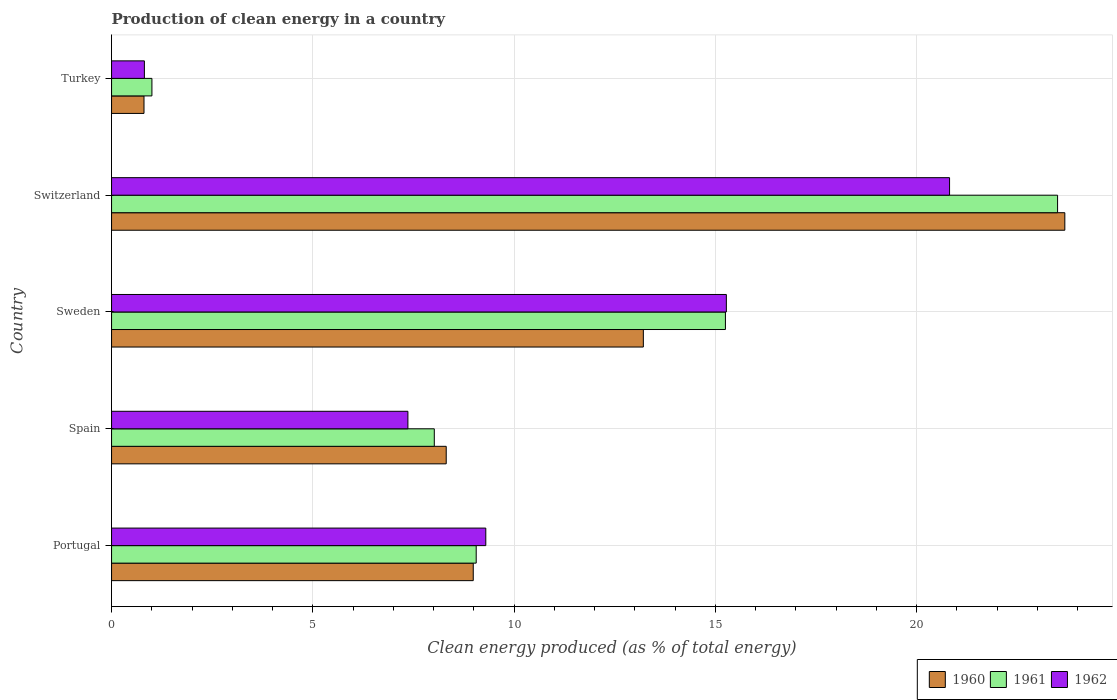Are the number of bars on each tick of the Y-axis equal?
Provide a succinct answer. Yes. How many bars are there on the 1st tick from the top?
Your answer should be compact. 3. How many bars are there on the 3rd tick from the bottom?
Provide a short and direct response. 3. What is the label of the 2nd group of bars from the top?
Your response must be concise. Switzerland. In how many cases, is the number of bars for a given country not equal to the number of legend labels?
Your response must be concise. 0. What is the percentage of clean energy produced in 1960 in Spain?
Give a very brief answer. 8.31. Across all countries, what is the maximum percentage of clean energy produced in 1961?
Offer a very short reply. 23.5. Across all countries, what is the minimum percentage of clean energy produced in 1960?
Make the answer very short. 0.81. In which country was the percentage of clean energy produced in 1961 maximum?
Keep it short and to the point. Switzerland. What is the total percentage of clean energy produced in 1960 in the graph?
Ensure brevity in your answer.  55. What is the difference between the percentage of clean energy produced in 1962 in Portugal and that in Turkey?
Your response must be concise. 8.48. What is the difference between the percentage of clean energy produced in 1962 in Switzerland and the percentage of clean energy produced in 1960 in Portugal?
Your answer should be compact. 11.83. What is the average percentage of clean energy produced in 1961 per country?
Your answer should be compact. 11.37. What is the difference between the percentage of clean energy produced in 1960 and percentage of clean energy produced in 1961 in Turkey?
Give a very brief answer. -0.2. In how many countries, is the percentage of clean energy produced in 1961 greater than 20 %?
Provide a short and direct response. 1. What is the ratio of the percentage of clean energy produced in 1960 in Portugal to that in Turkey?
Keep it short and to the point. 11.15. Is the percentage of clean energy produced in 1962 in Portugal less than that in Switzerland?
Your answer should be compact. Yes. Is the difference between the percentage of clean energy produced in 1960 in Portugal and Spain greater than the difference between the percentage of clean energy produced in 1961 in Portugal and Spain?
Make the answer very short. No. What is the difference between the highest and the second highest percentage of clean energy produced in 1961?
Provide a succinct answer. 8.25. What is the difference between the highest and the lowest percentage of clean energy produced in 1960?
Provide a succinct answer. 22.88. In how many countries, is the percentage of clean energy produced in 1961 greater than the average percentage of clean energy produced in 1961 taken over all countries?
Give a very brief answer. 2. Is the sum of the percentage of clean energy produced in 1962 in Sweden and Turkey greater than the maximum percentage of clean energy produced in 1961 across all countries?
Your response must be concise. No. Is it the case that in every country, the sum of the percentage of clean energy produced in 1961 and percentage of clean energy produced in 1960 is greater than the percentage of clean energy produced in 1962?
Offer a very short reply. Yes. How many bars are there?
Your response must be concise. 15. Does the graph contain any zero values?
Keep it short and to the point. No. Does the graph contain grids?
Give a very brief answer. Yes. What is the title of the graph?
Provide a short and direct response. Production of clean energy in a country. Does "1998" appear as one of the legend labels in the graph?
Your response must be concise. No. What is the label or title of the X-axis?
Your answer should be very brief. Clean energy produced (as % of total energy). What is the Clean energy produced (as % of total energy) of 1960 in Portugal?
Your answer should be very brief. 8.99. What is the Clean energy produced (as % of total energy) in 1961 in Portugal?
Your response must be concise. 9.06. What is the Clean energy produced (as % of total energy) of 1962 in Portugal?
Your answer should be very brief. 9.3. What is the Clean energy produced (as % of total energy) in 1960 in Spain?
Offer a terse response. 8.31. What is the Clean energy produced (as % of total energy) in 1961 in Spain?
Keep it short and to the point. 8.02. What is the Clean energy produced (as % of total energy) of 1962 in Spain?
Keep it short and to the point. 7.36. What is the Clean energy produced (as % of total energy) of 1960 in Sweden?
Offer a terse response. 13.21. What is the Clean energy produced (as % of total energy) of 1961 in Sweden?
Your answer should be very brief. 15.25. What is the Clean energy produced (as % of total energy) of 1962 in Sweden?
Make the answer very short. 15.27. What is the Clean energy produced (as % of total energy) of 1960 in Switzerland?
Provide a short and direct response. 23.68. What is the Clean energy produced (as % of total energy) of 1961 in Switzerland?
Make the answer very short. 23.5. What is the Clean energy produced (as % of total energy) of 1962 in Switzerland?
Keep it short and to the point. 20.82. What is the Clean energy produced (as % of total energy) in 1960 in Turkey?
Provide a succinct answer. 0.81. What is the Clean energy produced (as % of total energy) of 1961 in Turkey?
Make the answer very short. 1. What is the Clean energy produced (as % of total energy) in 1962 in Turkey?
Your answer should be very brief. 0.82. Across all countries, what is the maximum Clean energy produced (as % of total energy) in 1960?
Keep it short and to the point. 23.68. Across all countries, what is the maximum Clean energy produced (as % of total energy) of 1961?
Offer a very short reply. 23.5. Across all countries, what is the maximum Clean energy produced (as % of total energy) of 1962?
Provide a short and direct response. 20.82. Across all countries, what is the minimum Clean energy produced (as % of total energy) of 1960?
Offer a very short reply. 0.81. Across all countries, what is the minimum Clean energy produced (as % of total energy) of 1961?
Keep it short and to the point. 1. Across all countries, what is the minimum Clean energy produced (as % of total energy) in 1962?
Your response must be concise. 0.82. What is the total Clean energy produced (as % of total energy) of 1960 in the graph?
Your answer should be compact. 55. What is the total Clean energy produced (as % of total energy) in 1961 in the graph?
Offer a terse response. 56.83. What is the total Clean energy produced (as % of total energy) in 1962 in the graph?
Give a very brief answer. 53.57. What is the difference between the Clean energy produced (as % of total energy) of 1960 in Portugal and that in Spain?
Make the answer very short. 0.67. What is the difference between the Clean energy produced (as % of total energy) in 1961 in Portugal and that in Spain?
Offer a terse response. 1.04. What is the difference between the Clean energy produced (as % of total energy) in 1962 in Portugal and that in Spain?
Provide a succinct answer. 1.94. What is the difference between the Clean energy produced (as % of total energy) in 1960 in Portugal and that in Sweden?
Your answer should be very brief. -4.23. What is the difference between the Clean energy produced (as % of total energy) in 1961 in Portugal and that in Sweden?
Offer a very short reply. -6.19. What is the difference between the Clean energy produced (as % of total energy) of 1962 in Portugal and that in Sweden?
Your answer should be compact. -5.98. What is the difference between the Clean energy produced (as % of total energy) of 1960 in Portugal and that in Switzerland?
Give a very brief answer. -14.7. What is the difference between the Clean energy produced (as % of total energy) of 1961 in Portugal and that in Switzerland?
Offer a very short reply. -14.44. What is the difference between the Clean energy produced (as % of total energy) of 1962 in Portugal and that in Switzerland?
Your response must be concise. -11.52. What is the difference between the Clean energy produced (as % of total energy) of 1960 in Portugal and that in Turkey?
Ensure brevity in your answer.  8.18. What is the difference between the Clean energy produced (as % of total energy) in 1961 in Portugal and that in Turkey?
Give a very brief answer. 8.06. What is the difference between the Clean energy produced (as % of total energy) in 1962 in Portugal and that in Turkey?
Offer a terse response. 8.48. What is the difference between the Clean energy produced (as % of total energy) in 1960 in Spain and that in Sweden?
Ensure brevity in your answer.  -4.9. What is the difference between the Clean energy produced (as % of total energy) in 1961 in Spain and that in Sweden?
Give a very brief answer. -7.23. What is the difference between the Clean energy produced (as % of total energy) of 1962 in Spain and that in Sweden?
Your answer should be compact. -7.91. What is the difference between the Clean energy produced (as % of total energy) in 1960 in Spain and that in Switzerland?
Provide a short and direct response. -15.37. What is the difference between the Clean energy produced (as % of total energy) in 1961 in Spain and that in Switzerland?
Provide a short and direct response. -15.48. What is the difference between the Clean energy produced (as % of total energy) of 1962 in Spain and that in Switzerland?
Provide a short and direct response. -13.46. What is the difference between the Clean energy produced (as % of total energy) of 1960 in Spain and that in Turkey?
Keep it short and to the point. 7.51. What is the difference between the Clean energy produced (as % of total energy) of 1961 in Spain and that in Turkey?
Keep it short and to the point. 7.02. What is the difference between the Clean energy produced (as % of total energy) of 1962 in Spain and that in Turkey?
Offer a very short reply. 6.55. What is the difference between the Clean energy produced (as % of total energy) of 1960 in Sweden and that in Switzerland?
Provide a short and direct response. -10.47. What is the difference between the Clean energy produced (as % of total energy) in 1961 in Sweden and that in Switzerland?
Offer a very short reply. -8.25. What is the difference between the Clean energy produced (as % of total energy) of 1962 in Sweden and that in Switzerland?
Offer a terse response. -5.55. What is the difference between the Clean energy produced (as % of total energy) of 1960 in Sweden and that in Turkey?
Your answer should be very brief. 12.4. What is the difference between the Clean energy produced (as % of total energy) in 1961 in Sweden and that in Turkey?
Offer a very short reply. 14.25. What is the difference between the Clean energy produced (as % of total energy) of 1962 in Sweden and that in Turkey?
Your answer should be compact. 14.46. What is the difference between the Clean energy produced (as % of total energy) of 1960 in Switzerland and that in Turkey?
Provide a short and direct response. 22.88. What is the difference between the Clean energy produced (as % of total energy) in 1961 in Switzerland and that in Turkey?
Offer a terse response. 22.5. What is the difference between the Clean energy produced (as % of total energy) of 1962 in Switzerland and that in Turkey?
Give a very brief answer. 20. What is the difference between the Clean energy produced (as % of total energy) of 1960 in Portugal and the Clean energy produced (as % of total energy) of 1961 in Spain?
Provide a short and direct response. 0.97. What is the difference between the Clean energy produced (as % of total energy) of 1960 in Portugal and the Clean energy produced (as % of total energy) of 1962 in Spain?
Your answer should be very brief. 1.62. What is the difference between the Clean energy produced (as % of total energy) of 1961 in Portugal and the Clean energy produced (as % of total energy) of 1962 in Spain?
Your answer should be compact. 1.7. What is the difference between the Clean energy produced (as % of total energy) in 1960 in Portugal and the Clean energy produced (as % of total energy) in 1961 in Sweden?
Keep it short and to the point. -6.26. What is the difference between the Clean energy produced (as % of total energy) of 1960 in Portugal and the Clean energy produced (as % of total energy) of 1962 in Sweden?
Make the answer very short. -6.29. What is the difference between the Clean energy produced (as % of total energy) of 1961 in Portugal and the Clean energy produced (as % of total energy) of 1962 in Sweden?
Make the answer very short. -6.21. What is the difference between the Clean energy produced (as % of total energy) of 1960 in Portugal and the Clean energy produced (as % of total energy) of 1961 in Switzerland?
Make the answer very short. -14.52. What is the difference between the Clean energy produced (as % of total energy) of 1960 in Portugal and the Clean energy produced (as % of total energy) of 1962 in Switzerland?
Provide a short and direct response. -11.83. What is the difference between the Clean energy produced (as % of total energy) in 1961 in Portugal and the Clean energy produced (as % of total energy) in 1962 in Switzerland?
Your answer should be very brief. -11.76. What is the difference between the Clean energy produced (as % of total energy) in 1960 in Portugal and the Clean energy produced (as % of total energy) in 1961 in Turkey?
Give a very brief answer. 7.98. What is the difference between the Clean energy produced (as % of total energy) of 1960 in Portugal and the Clean energy produced (as % of total energy) of 1962 in Turkey?
Your response must be concise. 8.17. What is the difference between the Clean energy produced (as % of total energy) in 1961 in Portugal and the Clean energy produced (as % of total energy) in 1962 in Turkey?
Offer a very short reply. 8.24. What is the difference between the Clean energy produced (as % of total energy) in 1960 in Spain and the Clean energy produced (as % of total energy) in 1961 in Sweden?
Give a very brief answer. -6.94. What is the difference between the Clean energy produced (as % of total energy) in 1960 in Spain and the Clean energy produced (as % of total energy) in 1962 in Sweden?
Your response must be concise. -6.96. What is the difference between the Clean energy produced (as % of total energy) in 1961 in Spain and the Clean energy produced (as % of total energy) in 1962 in Sweden?
Keep it short and to the point. -7.26. What is the difference between the Clean energy produced (as % of total energy) in 1960 in Spain and the Clean energy produced (as % of total energy) in 1961 in Switzerland?
Your response must be concise. -15.19. What is the difference between the Clean energy produced (as % of total energy) in 1960 in Spain and the Clean energy produced (as % of total energy) in 1962 in Switzerland?
Your answer should be compact. -12.5. What is the difference between the Clean energy produced (as % of total energy) in 1961 in Spain and the Clean energy produced (as % of total energy) in 1962 in Switzerland?
Offer a terse response. -12.8. What is the difference between the Clean energy produced (as % of total energy) of 1960 in Spain and the Clean energy produced (as % of total energy) of 1961 in Turkey?
Ensure brevity in your answer.  7.31. What is the difference between the Clean energy produced (as % of total energy) of 1960 in Spain and the Clean energy produced (as % of total energy) of 1962 in Turkey?
Provide a short and direct response. 7.5. What is the difference between the Clean energy produced (as % of total energy) in 1961 in Spain and the Clean energy produced (as % of total energy) in 1962 in Turkey?
Your answer should be very brief. 7.2. What is the difference between the Clean energy produced (as % of total energy) in 1960 in Sweden and the Clean energy produced (as % of total energy) in 1961 in Switzerland?
Your answer should be very brief. -10.29. What is the difference between the Clean energy produced (as % of total energy) in 1960 in Sweden and the Clean energy produced (as % of total energy) in 1962 in Switzerland?
Your answer should be very brief. -7.61. What is the difference between the Clean energy produced (as % of total energy) of 1961 in Sweden and the Clean energy produced (as % of total energy) of 1962 in Switzerland?
Your response must be concise. -5.57. What is the difference between the Clean energy produced (as % of total energy) of 1960 in Sweden and the Clean energy produced (as % of total energy) of 1961 in Turkey?
Offer a terse response. 12.21. What is the difference between the Clean energy produced (as % of total energy) of 1960 in Sweden and the Clean energy produced (as % of total energy) of 1962 in Turkey?
Give a very brief answer. 12.4. What is the difference between the Clean energy produced (as % of total energy) in 1961 in Sweden and the Clean energy produced (as % of total energy) in 1962 in Turkey?
Give a very brief answer. 14.43. What is the difference between the Clean energy produced (as % of total energy) of 1960 in Switzerland and the Clean energy produced (as % of total energy) of 1961 in Turkey?
Your answer should be very brief. 22.68. What is the difference between the Clean energy produced (as % of total energy) of 1960 in Switzerland and the Clean energy produced (as % of total energy) of 1962 in Turkey?
Provide a succinct answer. 22.87. What is the difference between the Clean energy produced (as % of total energy) in 1961 in Switzerland and the Clean energy produced (as % of total energy) in 1962 in Turkey?
Keep it short and to the point. 22.69. What is the average Clean energy produced (as % of total energy) in 1960 per country?
Offer a terse response. 11. What is the average Clean energy produced (as % of total energy) in 1961 per country?
Your response must be concise. 11.37. What is the average Clean energy produced (as % of total energy) of 1962 per country?
Your response must be concise. 10.71. What is the difference between the Clean energy produced (as % of total energy) in 1960 and Clean energy produced (as % of total energy) in 1961 in Portugal?
Provide a short and direct response. -0.07. What is the difference between the Clean energy produced (as % of total energy) of 1960 and Clean energy produced (as % of total energy) of 1962 in Portugal?
Give a very brief answer. -0.31. What is the difference between the Clean energy produced (as % of total energy) in 1961 and Clean energy produced (as % of total energy) in 1962 in Portugal?
Your answer should be compact. -0.24. What is the difference between the Clean energy produced (as % of total energy) of 1960 and Clean energy produced (as % of total energy) of 1961 in Spain?
Give a very brief answer. 0.3. What is the difference between the Clean energy produced (as % of total energy) in 1960 and Clean energy produced (as % of total energy) in 1962 in Spain?
Keep it short and to the point. 0.95. What is the difference between the Clean energy produced (as % of total energy) in 1961 and Clean energy produced (as % of total energy) in 1962 in Spain?
Provide a short and direct response. 0.66. What is the difference between the Clean energy produced (as % of total energy) in 1960 and Clean energy produced (as % of total energy) in 1961 in Sweden?
Give a very brief answer. -2.04. What is the difference between the Clean energy produced (as % of total energy) of 1960 and Clean energy produced (as % of total energy) of 1962 in Sweden?
Your answer should be compact. -2.06. What is the difference between the Clean energy produced (as % of total energy) in 1961 and Clean energy produced (as % of total energy) in 1962 in Sweden?
Offer a terse response. -0.02. What is the difference between the Clean energy produced (as % of total energy) in 1960 and Clean energy produced (as % of total energy) in 1961 in Switzerland?
Provide a succinct answer. 0.18. What is the difference between the Clean energy produced (as % of total energy) of 1960 and Clean energy produced (as % of total energy) of 1962 in Switzerland?
Provide a succinct answer. 2.86. What is the difference between the Clean energy produced (as % of total energy) of 1961 and Clean energy produced (as % of total energy) of 1962 in Switzerland?
Keep it short and to the point. 2.68. What is the difference between the Clean energy produced (as % of total energy) in 1960 and Clean energy produced (as % of total energy) in 1961 in Turkey?
Offer a very short reply. -0.2. What is the difference between the Clean energy produced (as % of total energy) in 1960 and Clean energy produced (as % of total energy) in 1962 in Turkey?
Give a very brief answer. -0.01. What is the difference between the Clean energy produced (as % of total energy) in 1961 and Clean energy produced (as % of total energy) in 1962 in Turkey?
Your answer should be very brief. 0.19. What is the ratio of the Clean energy produced (as % of total energy) in 1960 in Portugal to that in Spain?
Make the answer very short. 1.08. What is the ratio of the Clean energy produced (as % of total energy) in 1961 in Portugal to that in Spain?
Provide a short and direct response. 1.13. What is the ratio of the Clean energy produced (as % of total energy) of 1962 in Portugal to that in Spain?
Your response must be concise. 1.26. What is the ratio of the Clean energy produced (as % of total energy) in 1960 in Portugal to that in Sweden?
Ensure brevity in your answer.  0.68. What is the ratio of the Clean energy produced (as % of total energy) of 1961 in Portugal to that in Sweden?
Make the answer very short. 0.59. What is the ratio of the Clean energy produced (as % of total energy) in 1962 in Portugal to that in Sweden?
Keep it short and to the point. 0.61. What is the ratio of the Clean energy produced (as % of total energy) of 1960 in Portugal to that in Switzerland?
Offer a terse response. 0.38. What is the ratio of the Clean energy produced (as % of total energy) of 1961 in Portugal to that in Switzerland?
Your response must be concise. 0.39. What is the ratio of the Clean energy produced (as % of total energy) of 1962 in Portugal to that in Switzerland?
Ensure brevity in your answer.  0.45. What is the ratio of the Clean energy produced (as % of total energy) in 1960 in Portugal to that in Turkey?
Your answer should be very brief. 11.15. What is the ratio of the Clean energy produced (as % of total energy) of 1961 in Portugal to that in Turkey?
Provide a succinct answer. 9.03. What is the ratio of the Clean energy produced (as % of total energy) in 1962 in Portugal to that in Turkey?
Ensure brevity in your answer.  11.4. What is the ratio of the Clean energy produced (as % of total energy) in 1960 in Spain to that in Sweden?
Ensure brevity in your answer.  0.63. What is the ratio of the Clean energy produced (as % of total energy) of 1961 in Spain to that in Sweden?
Your answer should be very brief. 0.53. What is the ratio of the Clean energy produced (as % of total energy) of 1962 in Spain to that in Sweden?
Your answer should be very brief. 0.48. What is the ratio of the Clean energy produced (as % of total energy) of 1960 in Spain to that in Switzerland?
Your answer should be compact. 0.35. What is the ratio of the Clean energy produced (as % of total energy) in 1961 in Spain to that in Switzerland?
Provide a short and direct response. 0.34. What is the ratio of the Clean energy produced (as % of total energy) of 1962 in Spain to that in Switzerland?
Ensure brevity in your answer.  0.35. What is the ratio of the Clean energy produced (as % of total energy) in 1960 in Spain to that in Turkey?
Offer a terse response. 10.31. What is the ratio of the Clean energy produced (as % of total energy) of 1961 in Spain to that in Turkey?
Make the answer very short. 8. What is the ratio of the Clean energy produced (as % of total energy) in 1962 in Spain to that in Turkey?
Ensure brevity in your answer.  9.03. What is the ratio of the Clean energy produced (as % of total energy) in 1960 in Sweden to that in Switzerland?
Your answer should be very brief. 0.56. What is the ratio of the Clean energy produced (as % of total energy) in 1961 in Sweden to that in Switzerland?
Offer a very short reply. 0.65. What is the ratio of the Clean energy produced (as % of total energy) of 1962 in Sweden to that in Switzerland?
Keep it short and to the point. 0.73. What is the ratio of the Clean energy produced (as % of total energy) in 1960 in Sweden to that in Turkey?
Offer a very short reply. 16.39. What is the ratio of the Clean energy produced (as % of total energy) in 1961 in Sweden to that in Turkey?
Ensure brevity in your answer.  15.21. What is the ratio of the Clean energy produced (as % of total energy) in 1962 in Sweden to that in Turkey?
Your answer should be compact. 18.73. What is the ratio of the Clean energy produced (as % of total energy) in 1960 in Switzerland to that in Turkey?
Give a very brief answer. 29.38. What is the ratio of the Clean energy produced (as % of total energy) of 1961 in Switzerland to that in Turkey?
Make the answer very short. 23.44. What is the ratio of the Clean energy produced (as % of total energy) of 1962 in Switzerland to that in Turkey?
Provide a succinct answer. 25.53. What is the difference between the highest and the second highest Clean energy produced (as % of total energy) of 1960?
Offer a very short reply. 10.47. What is the difference between the highest and the second highest Clean energy produced (as % of total energy) of 1961?
Offer a terse response. 8.25. What is the difference between the highest and the second highest Clean energy produced (as % of total energy) in 1962?
Your answer should be very brief. 5.55. What is the difference between the highest and the lowest Clean energy produced (as % of total energy) of 1960?
Give a very brief answer. 22.88. What is the difference between the highest and the lowest Clean energy produced (as % of total energy) of 1961?
Give a very brief answer. 22.5. What is the difference between the highest and the lowest Clean energy produced (as % of total energy) of 1962?
Provide a short and direct response. 20. 